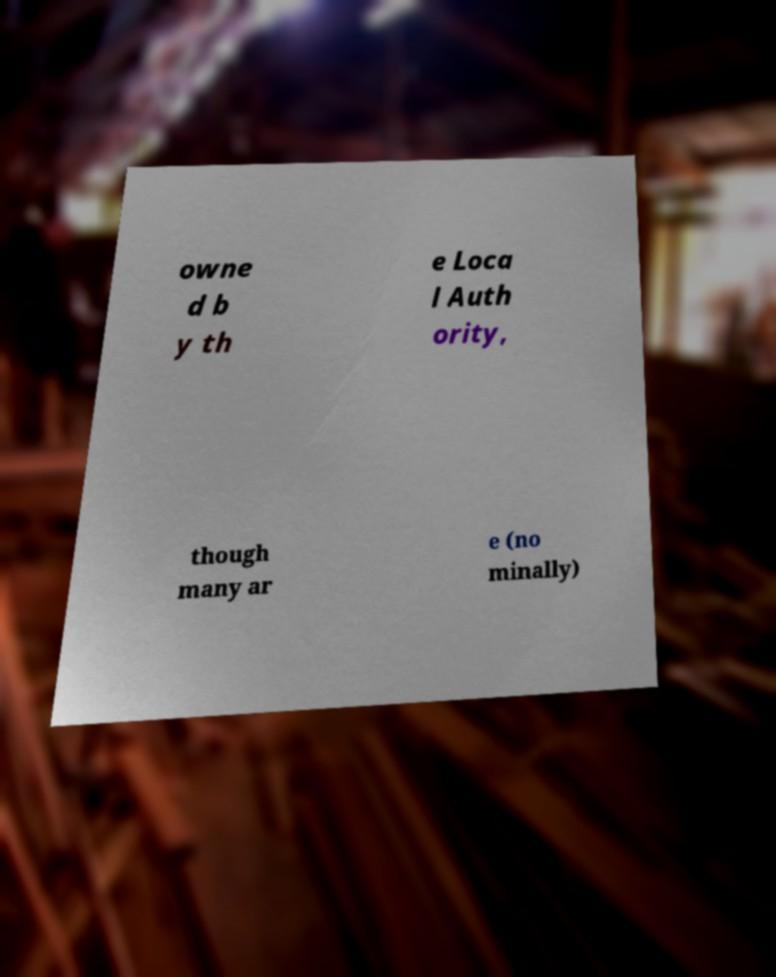Can you accurately transcribe the text from the provided image for me? owne d b y th e Loca l Auth ority, though many ar e (no minally) 